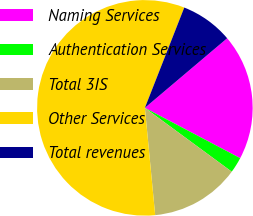Convert chart to OTSL. <chart><loc_0><loc_0><loc_500><loc_500><pie_chart><fcel>Naming Services<fcel>Authentication Services<fcel>Total 3IS<fcel>Other Services<fcel>Total revenues<nl><fcel>18.9%<fcel>2.36%<fcel>13.39%<fcel>57.48%<fcel>7.87%<nl></chart> 